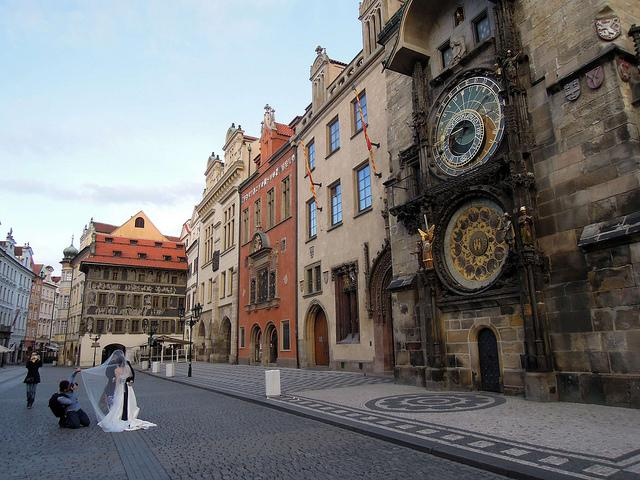What occasion is now photographed underneath the clock faces? Please explain your reasoning. marriage. The woman is in a wedding dress. 